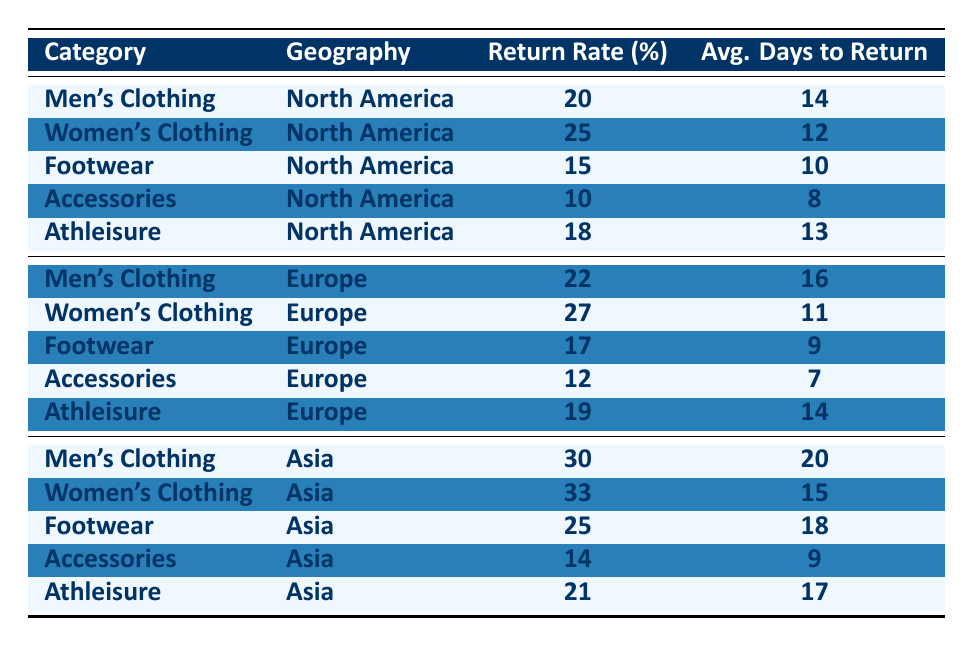What is the return rate for Women's Clothing in North America? I can find the Women's Clothing row under the North America section of the table. The return rate percentage listed there is 25.
Answer: 25 Which category has the highest return rate in Asia? Looking through the Asia section, I compare the return rates for all categories. Women's Clothing has the highest return rate at 33.
Answer: 33 What is the average days to return for Accessories in Europe? The Accessories row for Europe shows that the average days to return is 7.
Answer: 7 Is the return rate for Footwear higher in North America than in Europe? In North America, the return rate for Footwear is 15, while in Europe, it is 17. Since 15 is less than 17, the statement is false.
Answer: No What is the difference in return rates between Men's Clothing in Asia and Europe? From the table, Men's Clothing return rates are 30 in Asia and 22 in Europe. The difference is calculated by subtracting 22 from 30, which equals 8.
Answer: 8 Which category has the shortest average days to return across all geographies? Evaluating the average days to return across all categories and geographies, Accessories in Europe has the shortest at 7 days.
Answer: 7 True or False: The return rate for Athleisure is the same in North America and Europe. In North America, the return rate for Athleisure is 18, while in Europe it is 19. Since these values are not the same, the statement is false.
Answer: No What category in North America has the lowest return rate? I look at all return rates for North America and find Accessories with a return rate of 10, which is the lowest compared to others.
Answer: Accessories What is the total average days to return for all categories in Asia? I add the average days to return for all categories in Asia: 20 (Men's) + 15 (Women's) + 18 (Footwear) + 9 (Accessories) + 17 (Athleisure) = 79, and divide by the 5 categories to find the average, which is 79/5 = 15.8.
Answer: 15.8 